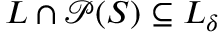<formula> <loc_0><loc_0><loc_500><loc_500>L \cap { \mathcal { P } } ( S ) \subseteq L _ { \delta }</formula> 